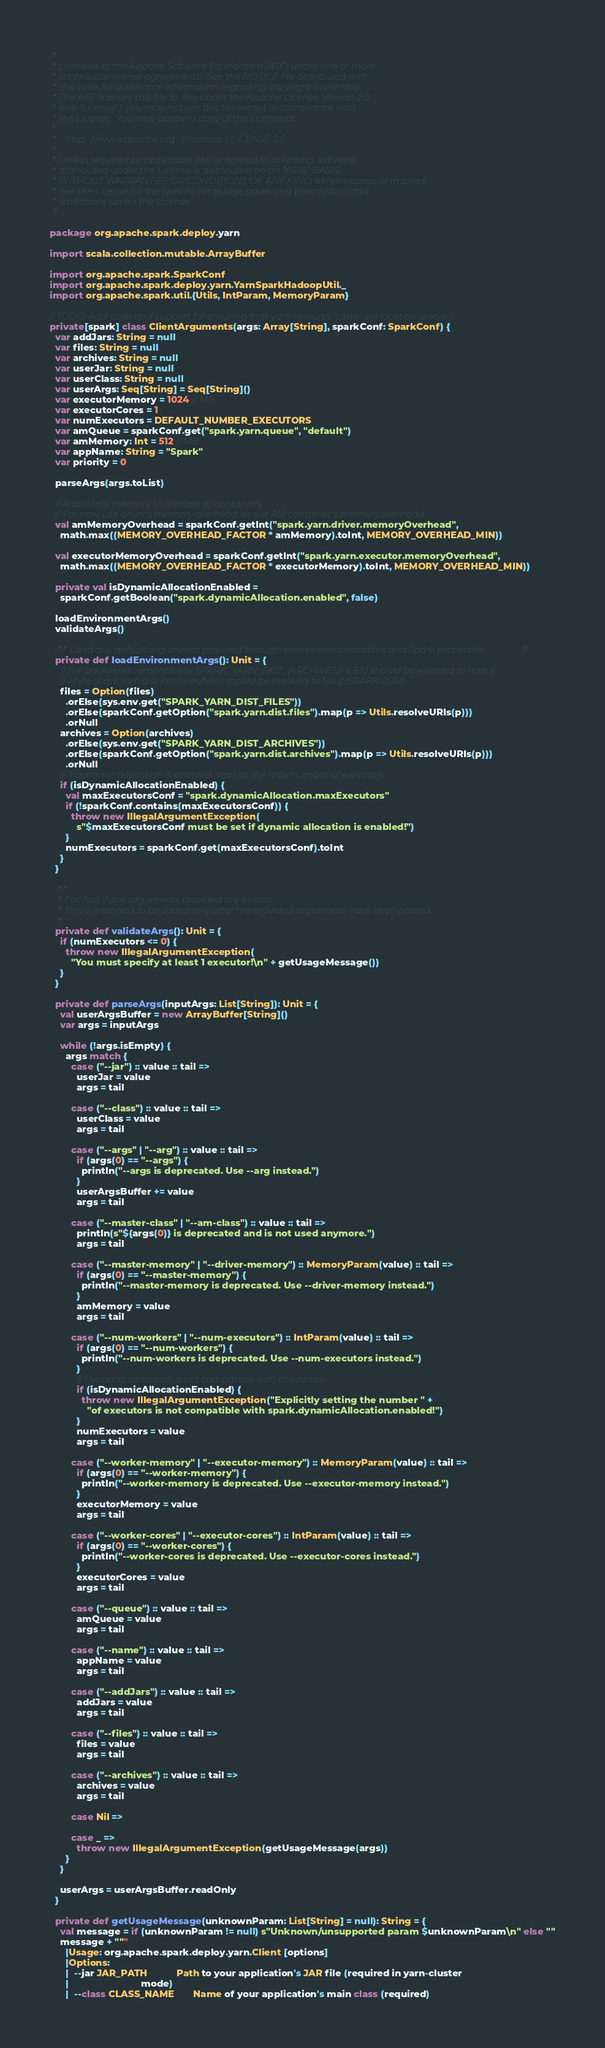Convert code to text. <code><loc_0><loc_0><loc_500><loc_500><_Scala_>/*
 * Licensed to the Apache Software Foundation (ASF) under one or more
 * contributor license agreements.  See the NOTICE file distributed with
 * this work for additional information regarding copyright ownership.
 * The ASF licenses this file to You under the Apache License, Version 2.0
 * (the "License"); you may not use this file except in compliance with
 * the License.  You may obtain a copy of the License at
 *
 *    http://www.apache.org/licenses/LICENSE-2.0
 *
 * Unless required by applicable law or agreed to in writing, software
 * distributed under the License is distributed on an "AS IS" BASIS,
 * WITHOUT WARRANTIES OR CONDITIONS OF ANY KIND, either express or implied.
 * See the License for the specific language governing permissions and
 * limitations under the License.
 */

package org.apache.spark.deploy.yarn

import scala.collection.mutable.ArrayBuffer

import org.apache.spark.SparkConf
import org.apache.spark.deploy.yarn.YarnSparkHadoopUtil._
import org.apache.spark.util.{Utils, IntParam, MemoryParam}

// TODO: Add code and support for ensuring that yarn resource 'tasks' are location aware !
private[spark] class ClientArguments(args: Array[String], sparkConf: SparkConf) {
  var addJars: String = null
  var files: String = null
  var archives: String = null
  var userJar: String = null
  var userClass: String = null
  var userArgs: Seq[String] = Seq[String]()
  var executorMemory = 1024 // MB
  var executorCores = 1
  var numExecutors = DEFAULT_NUMBER_EXECUTORS
  var amQueue = sparkConf.get("spark.yarn.queue", "default")
  var amMemory: Int = 512 // MB
  var appName: String = "Spark"
  var priority = 0

  parseArgs(args.toList)

  // Additional memory to allocate to containers
  // For now, use driver's memory overhead as our AM container's memory overhead
  val amMemoryOverhead = sparkConf.getInt("spark.yarn.driver.memoryOverhead",
    math.max((MEMORY_OVERHEAD_FACTOR * amMemory).toInt, MEMORY_OVERHEAD_MIN))

  val executorMemoryOverhead = sparkConf.getInt("spark.yarn.executor.memoryOverhead",
    math.max((MEMORY_OVERHEAD_FACTOR * executorMemory).toInt, MEMORY_OVERHEAD_MIN))

  private val isDynamicAllocationEnabled =
    sparkConf.getBoolean("spark.dynamicAllocation.enabled", false)

  loadEnvironmentArgs()
  validateArgs()

  /** Load any default arguments provided through environment variables and Spark properties. */
  private def loadEnvironmentArgs(): Unit = {
    // For backward compatibility, SPARK_YARN_DIST_{ARCHIVES/FILES} should be resolved to hdfs://,
    // while spark.yarn.dist.{archives/files} should be resolved to file:// (SPARK-2051).
    files = Option(files)
      .orElse(sys.env.get("SPARK_YARN_DIST_FILES"))
      .orElse(sparkConf.getOption("spark.yarn.dist.files").map(p => Utils.resolveURIs(p)))
      .orNull
    archives = Option(archives)
      .orElse(sys.env.get("SPARK_YARN_DIST_ARCHIVES"))
      .orElse(sparkConf.getOption("spark.yarn.dist.archives").map(p => Utils.resolveURIs(p)))
      .orNull
    // If dynamic allocation is enabled, start at the max number of executors
    if (isDynamicAllocationEnabled) {
      val maxExecutorsConf = "spark.dynamicAllocation.maxExecutors"
      if (!sparkConf.contains(maxExecutorsConf)) {
        throw new IllegalArgumentException(
          s"$maxExecutorsConf must be set if dynamic allocation is enabled!")
      }
      numExecutors = sparkConf.get(maxExecutorsConf).toInt
    }
  }

  /**
   * Fail fast if any arguments provided are invalid.
   * This is intended to be called only after the provided arguments have been parsed.
   */
  private def validateArgs(): Unit = {
    if (numExecutors <= 0) {
      throw new IllegalArgumentException(
        "You must specify at least 1 executor!\n" + getUsageMessage())
    }
  }

  private def parseArgs(inputArgs: List[String]): Unit = {
    val userArgsBuffer = new ArrayBuffer[String]()
    var args = inputArgs

    while (!args.isEmpty) {
      args match {
        case ("--jar") :: value :: tail =>
          userJar = value
          args = tail

        case ("--class") :: value :: tail =>
          userClass = value
          args = tail

        case ("--args" | "--arg") :: value :: tail =>
          if (args(0) == "--args") {
            println("--args is deprecated. Use --arg instead.")
          }
          userArgsBuffer += value
          args = tail

        case ("--master-class" | "--am-class") :: value :: tail =>
          println(s"${args(0)} is deprecated and is not used anymore.")
          args = tail

        case ("--master-memory" | "--driver-memory") :: MemoryParam(value) :: tail =>
          if (args(0) == "--master-memory") {
            println("--master-memory is deprecated. Use --driver-memory instead.")
          }
          amMemory = value
          args = tail

        case ("--num-workers" | "--num-executors") :: IntParam(value) :: tail =>
          if (args(0) == "--num-workers") {
            println("--num-workers is deprecated. Use --num-executors instead.")
          }
          // Dynamic allocation is not compatible with this option
          if (isDynamicAllocationEnabled) {
            throw new IllegalArgumentException("Explicitly setting the number " +
              "of executors is not compatible with spark.dynamicAllocation.enabled!")
          }
          numExecutors = value
          args = tail

        case ("--worker-memory" | "--executor-memory") :: MemoryParam(value) :: tail =>
          if (args(0) == "--worker-memory") {
            println("--worker-memory is deprecated. Use --executor-memory instead.")
          }
          executorMemory = value
          args = tail

        case ("--worker-cores" | "--executor-cores") :: IntParam(value) :: tail =>
          if (args(0) == "--worker-cores") {
            println("--worker-cores is deprecated. Use --executor-cores instead.")
          }
          executorCores = value
          args = tail

        case ("--queue") :: value :: tail =>
          amQueue = value
          args = tail

        case ("--name") :: value :: tail =>
          appName = value
          args = tail

        case ("--addJars") :: value :: tail =>
          addJars = value
          args = tail

        case ("--files") :: value :: tail =>
          files = value
          args = tail

        case ("--archives") :: value :: tail =>
          archives = value
          args = tail

        case Nil =>

        case _ =>
          throw new IllegalArgumentException(getUsageMessage(args))
      }
    }

    userArgs = userArgsBuffer.readOnly
  }

  private def getUsageMessage(unknownParam: List[String] = null): String = {
    val message = if (unknownParam != null) s"Unknown/unsupported param $unknownParam\n" else ""
    message + """
      |Usage: org.apache.spark.deploy.yarn.Client [options]
      |Options:
      |  --jar JAR_PATH           Path to your application's JAR file (required in yarn-cluster
      |                           mode)
      |  --class CLASS_NAME       Name of your application's main class (required)</code> 